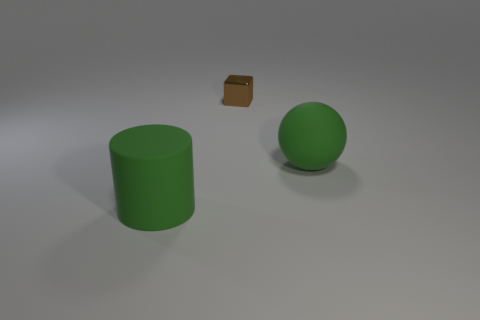Is there a green cylinder to the right of the thing to the right of the brown thing?
Offer a very short reply. No. Do the large object that is behind the large matte cylinder and the big cylinder have the same color?
Make the answer very short. Yes. What number of objects are big cylinders that are on the left side of the tiny brown metal block or small brown metal objects?
Provide a short and direct response. 2. What material is the large thing in front of the green rubber thing that is behind the green rubber cylinder to the left of the metal block?
Give a very brief answer. Rubber. Is the number of big balls left of the tiny brown thing greater than the number of brown metal blocks that are on the left side of the matte cylinder?
Provide a short and direct response. No. What number of cylinders are big matte objects or gray metal objects?
Ensure brevity in your answer.  1. How many small blocks are behind the green object behind the matte object in front of the matte sphere?
Make the answer very short. 1. There is a large cylinder that is the same color as the matte sphere; what is it made of?
Your answer should be very brief. Rubber. Is the number of tiny brown metal objects greater than the number of large green blocks?
Keep it short and to the point. Yes. Do the cylinder and the metal object have the same size?
Keep it short and to the point. No. 